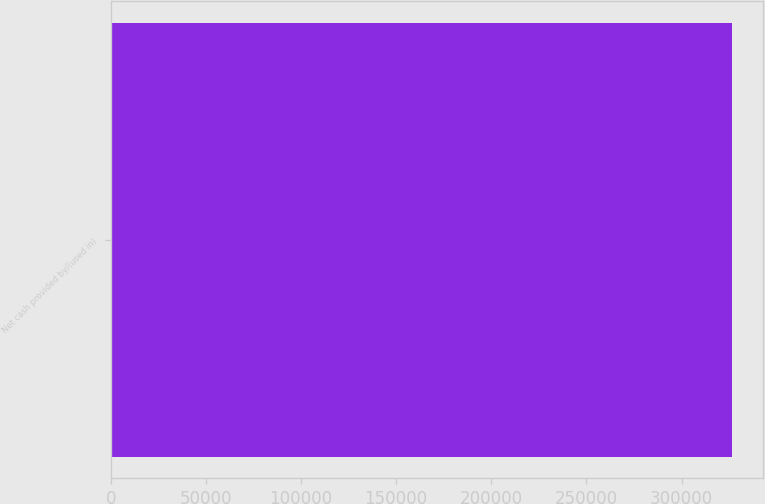<chart> <loc_0><loc_0><loc_500><loc_500><bar_chart><fcel>Net cash provided by/(used in)<nl><fcel>326535<nl></chart> 